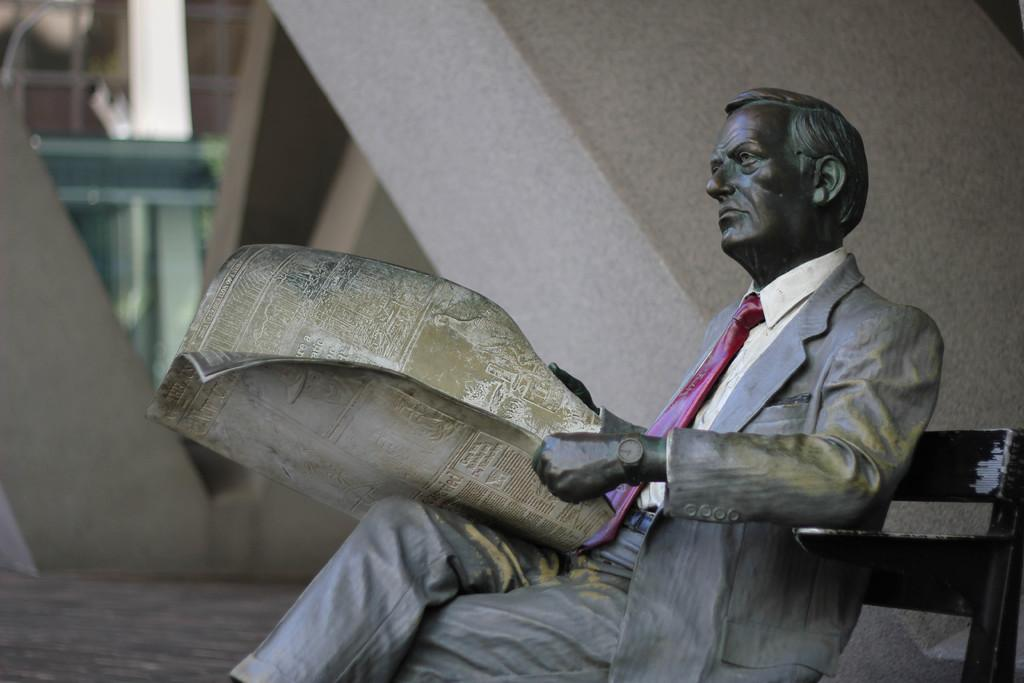What is the main subject in the image? There is a sculpture in the image. Where is the sculpture located? The sculpture is sitting on a bench. What is the sculpture holding in the image? The sculpture is holding a paper. Can you describe the background of the image? The background of the image is blurred. How many balloons are tied to the sculpture's wrist in the image? There are no balloons present in the image; the sculpture is holding a paper. What type of land can be seen in the background of the image? The background of the image is blurred, so it is not possible to determine the type of land in the image. 